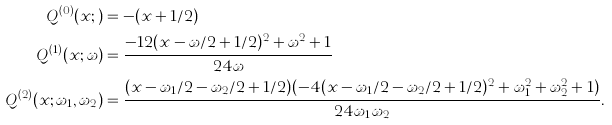<formula> <loc_0><loc_0><loc_500><loc_500>Q ^ { ( 0 ) } ( x ; ) & = - ( x + 1 / 2 ) \\ Q ^ { ( 1 ) } ( x ; \omega ) & = \frac { - 1 2 ( x - \omega / 2 + 1 / 2 ) ^ { 2 } + \omega ^ { 2 } + 1 } { 2 4 \omega } \\ Q ^ { ( 2 ) } ( x ; \omega _ { 1 } , \omega _ { 2 } ) & = \frac { ( x - \omega _ { 1 } / 2 - \omega _ { 2 } / 2 + 1 / 2 ) ( - 4 ( x - \omega _ { 1 } / 2 - \omega _ { 2 } / 2 + 1 / 2 ) ^ { 2 } + \omega _ { 1 } ^ { 2 } + \omega _ { 2 } ^ { 2 } + 1 ) } { 2 4 \omega _ { 1 } \omega _ { 2 } } .</formula> 